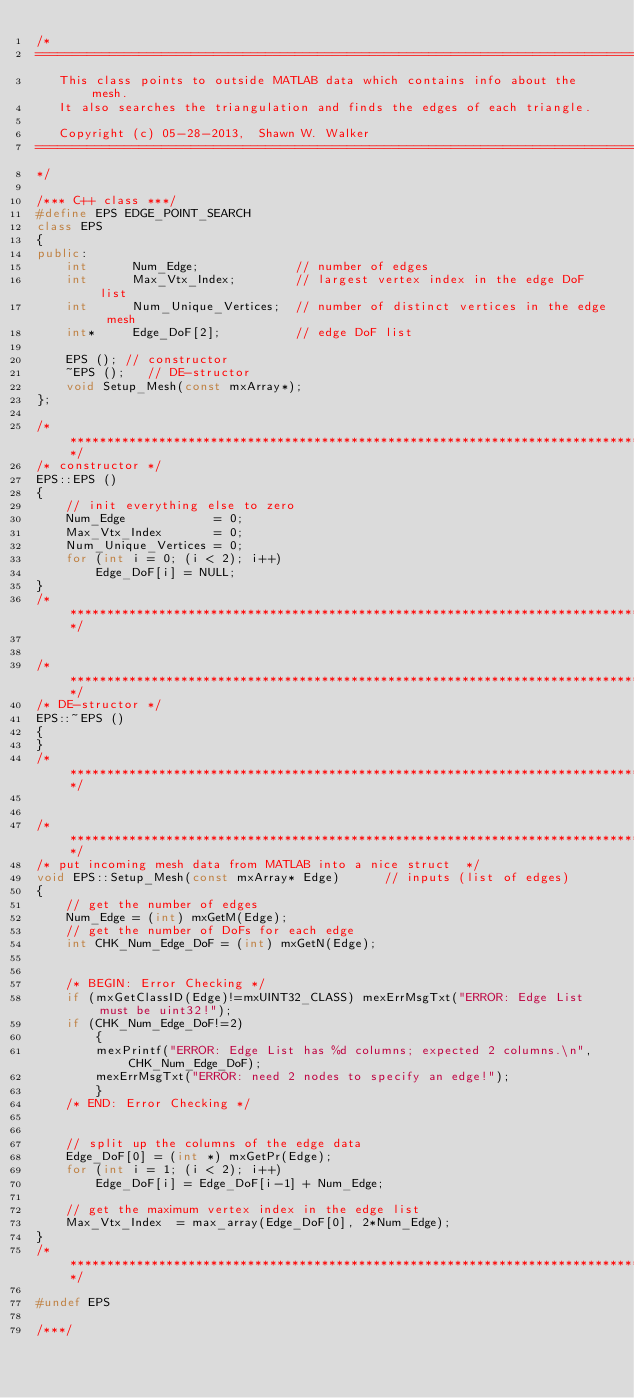<code> <loc_0><loc_0><loc_500><loc_500><_C++_>/*
============================================================================================
   This class points to outside MATLAB data which contains info about the mesh.
   It also searches the triangulation and finds the edges of each triangle.

   Copyright (c) 05-28-2013,  Shawn W. Walker
============================================================================================
*/

/*** C++ class ***/
#define EPS EDGE_POINT_SEARCH
class EPS
{
public:
    int      Num_Edge;             // number of edges
    int      Max_Vtx_Index;        // largest vertex index in the edge DoF list
    int      Num_Unique_Vertices;  // number of distinct vertices in the edge mesh
    int*     Edge_DoF[2];          // edge DoF list

    EPS (); // constructor
    ~EPS ();   // DE-structor
    void Setup_Mesh(const mxArray*);
};

/***************************************************************************************/
/* constructor */
EPS::EPS ()
{
    // init everything else to zero
    Num_Edge            = 0;
    Max_Vtx_Index       = 0;
    Num_Unique_Vertices = 0;
    for (int i = 0; (i < 2); i++)
        Edge_DoF[i] = NULL;
}
/***************************************************************************************/


/***************************************************************************************/
/* DE-structor */
EPS::~EPS ()
{
}
/***************************************************************************************/


/***************************************************************************************/
/* put incoming mesh data from MATLAB into a nice struct  */
void EPS::Setup_Mesh(const mxArray* Edge)      // inputs (list of edges)
{
    // get the number of edges
    Num_Edge = (int) mxGetM(Edge);
    // get the number of DoFs for each edge
    int CHK_Num_Edge_DoF = (int) mxGetN(Edge);


    /* BEGIN: Error Checking */
    if (mxGetClassID(Edge)!=mxUINT32_CLASS) mexErrMsgTxt("ERROR: Edge List must be uint32!");
    if (CHK_Num_Edge_DoF!=2)
        {
        mexPrintf("ERROR: Edge List has %d columns; expected 2 columns.\n", CHK_Num_Edge_DoF);
        mexErrMsgTxt("ERROR: need 2 nodes to specify an edge!");
        }
    /* END: Error Checking */


    // split up the columns of the edge data
    Edge_DoF[0] = (int *) mxGetPr(Edge);
    for (int i = 1; (i < 2); i++)
        Edge_DoF[i] = Edge_DoF[i-1] + Num_Edge;

    // get the maximum vertex index in the edge list
    Max_Vtx_Index  = max_array(Edge_DoF[0], 2*Num_Edge);
}
/***************************************************************************************/

#undef EPS

/***/
</code> 